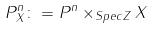<formula> <loc_0><loc_0><loc_500><loc_500>P _ { X } ^ { n } \colon = P ^ { n } \times _ { S p e c Z } X</formula> 